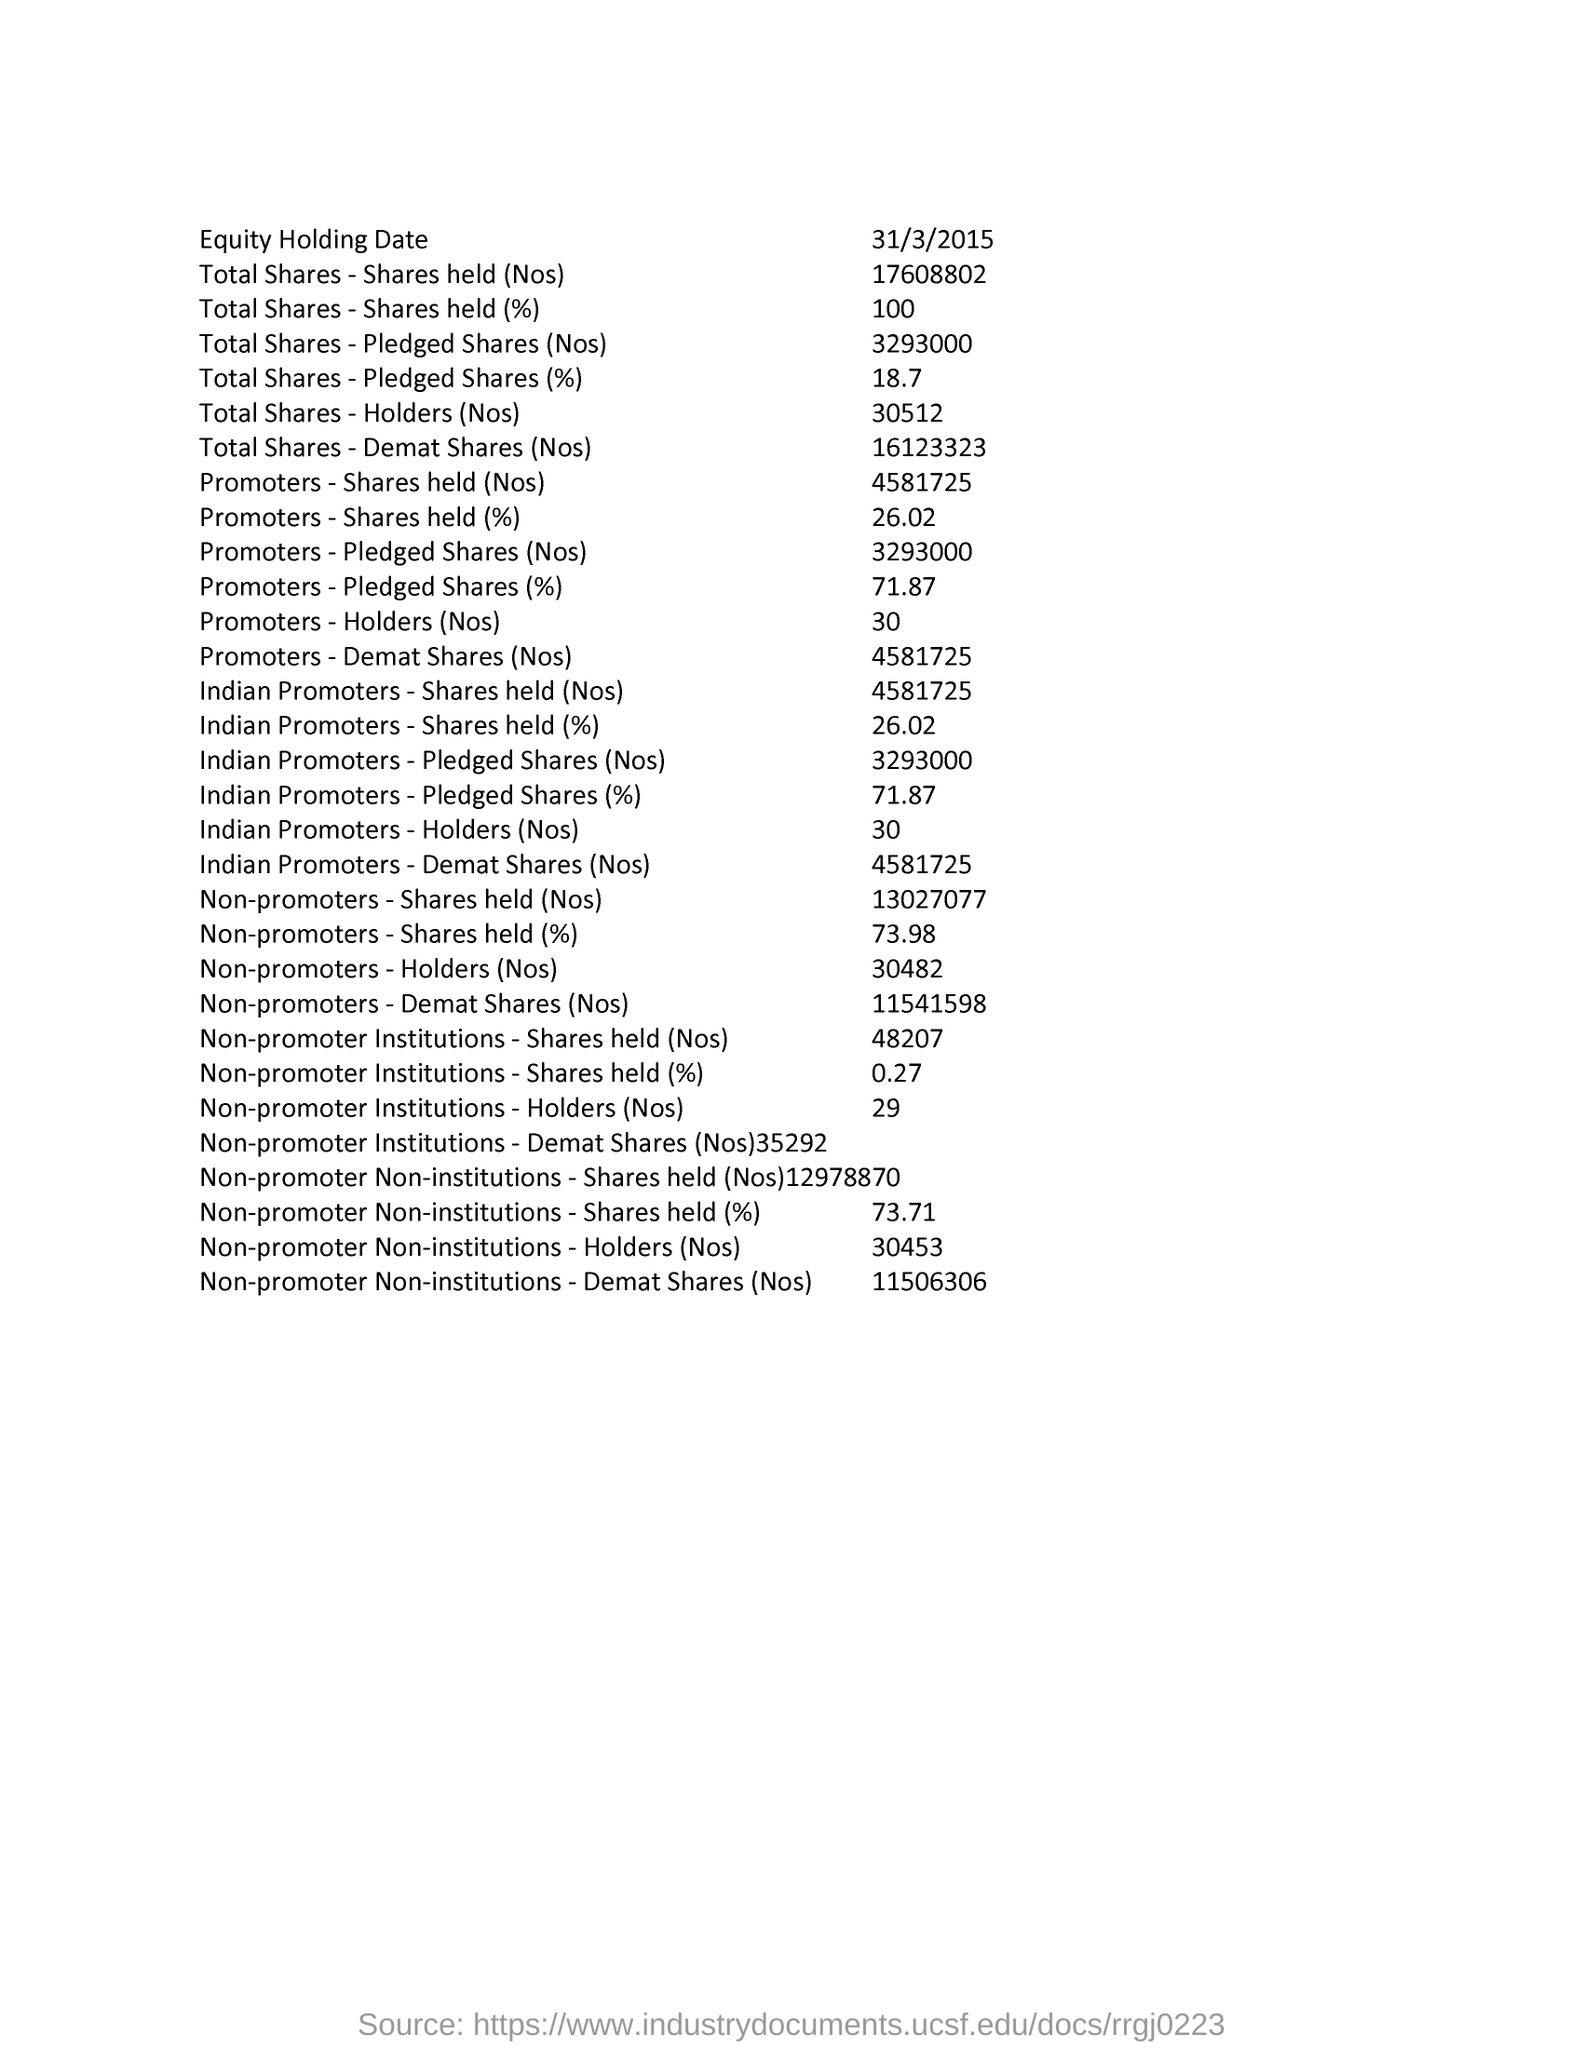Draw attention to some important aspects in this diagram. The equity holding date is March 31, 2015. 